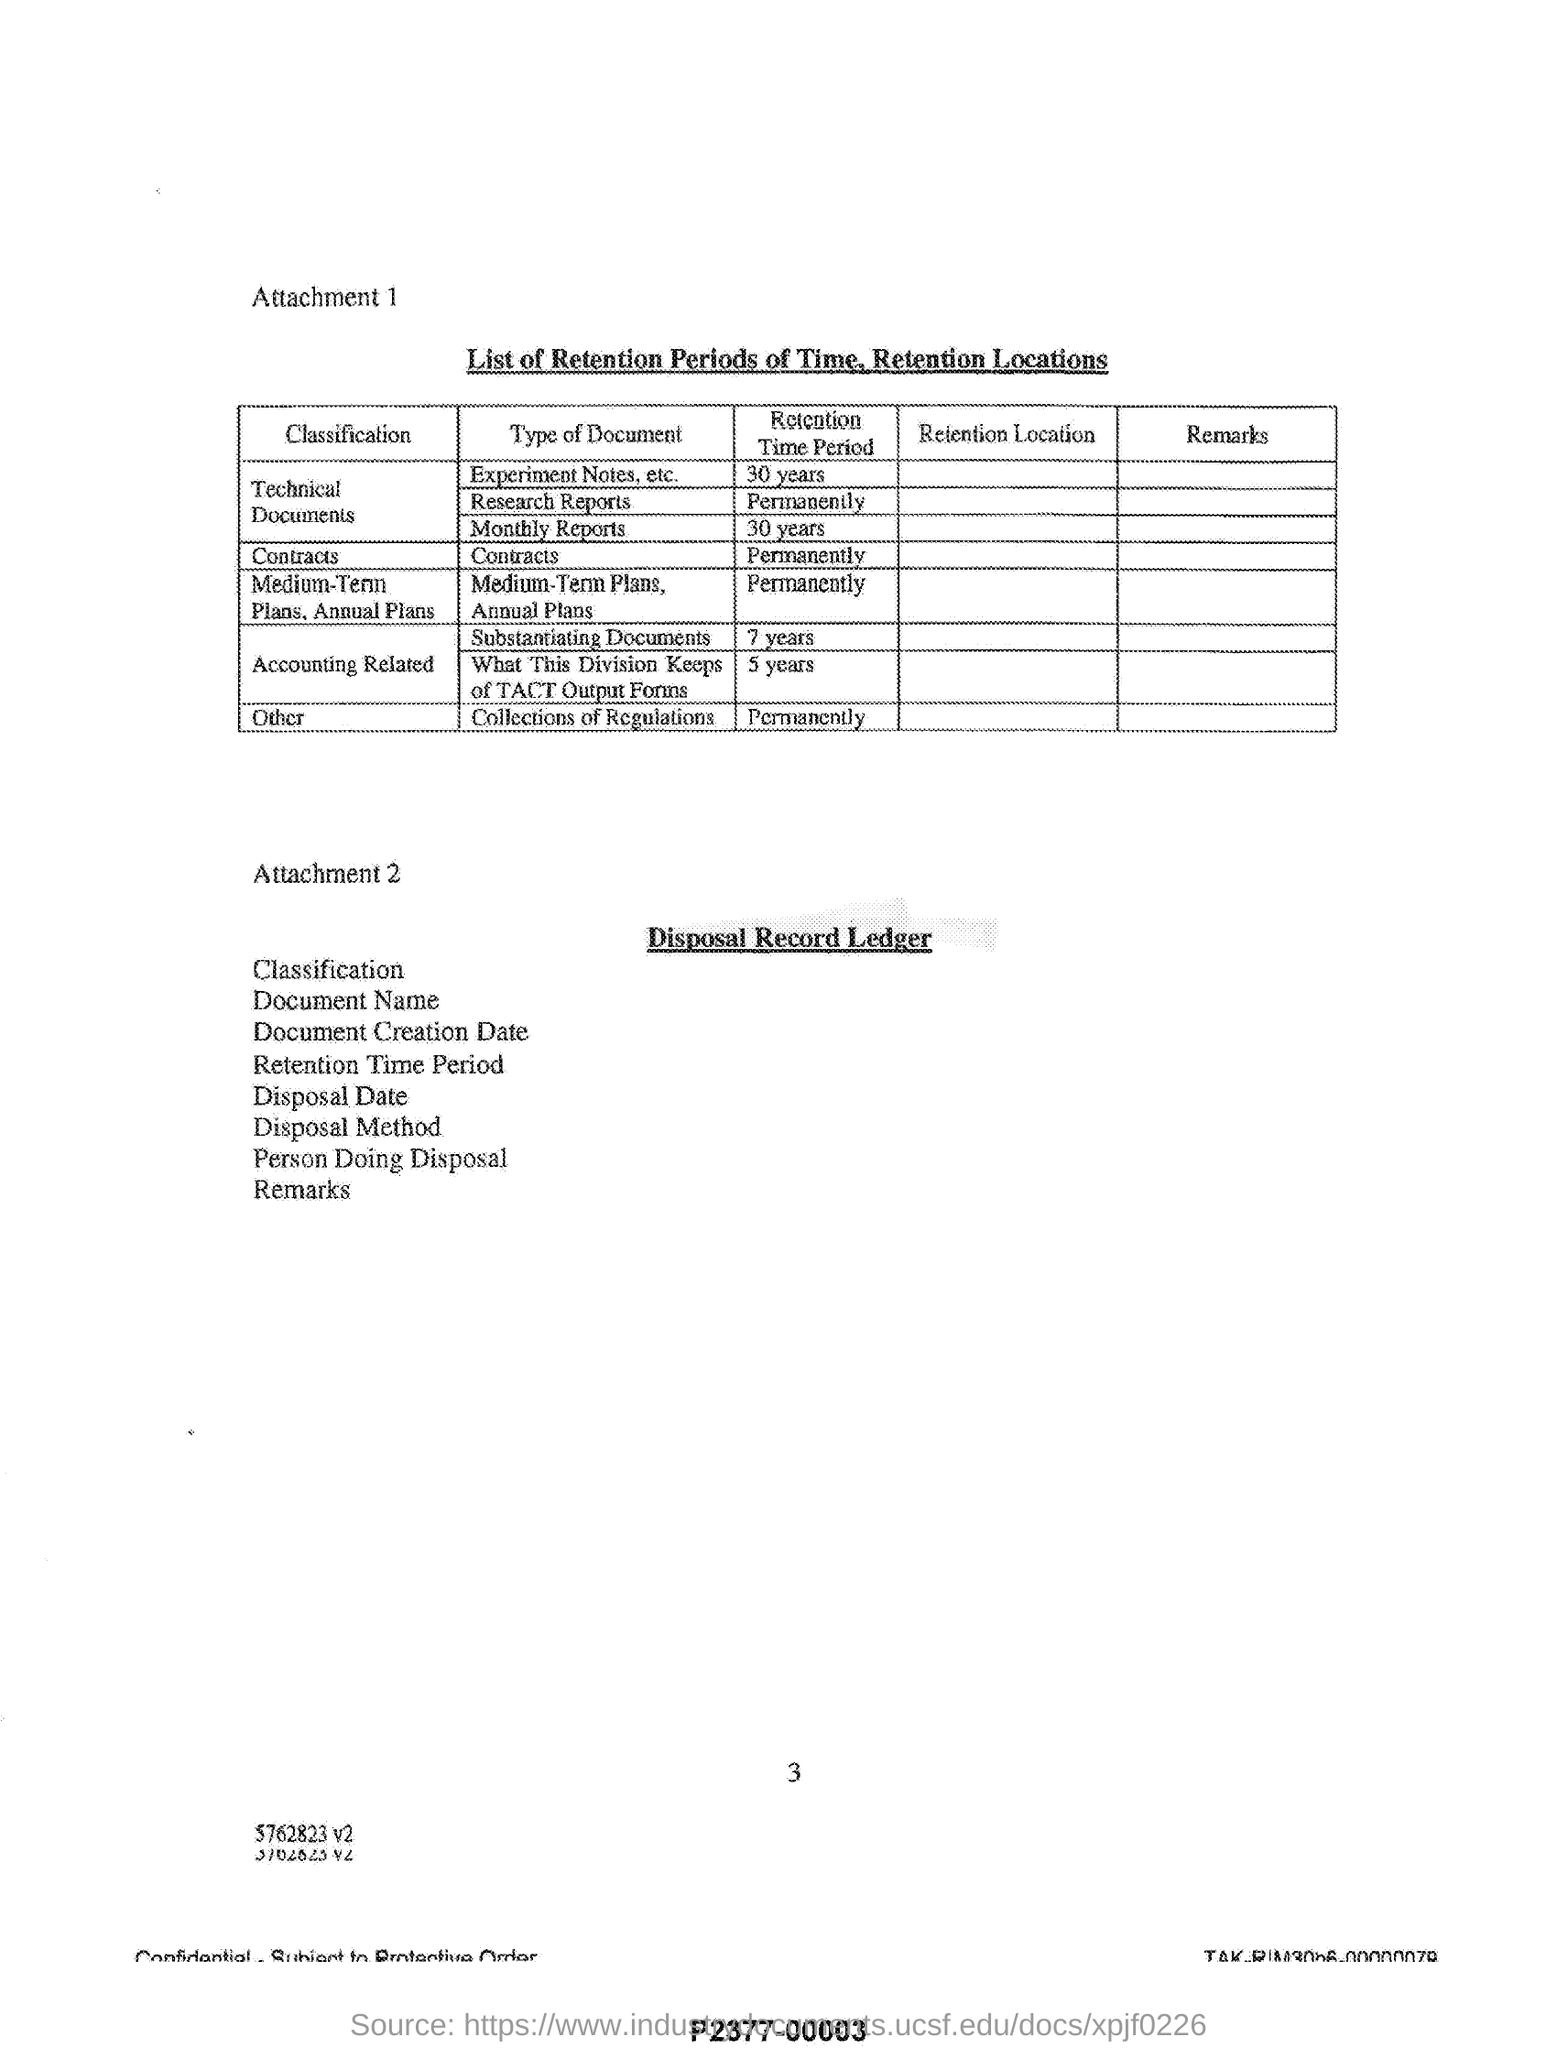What is the retention time period of monthly reports?
Make the answer very short. 30 years. What does Attachment 1 describes?
Your answer should be compact. List of Retention Periods of Time, Retention Locations. What is the retention time period of contracts?
Keep it short and to the point. Permanently. 